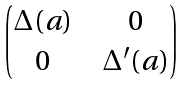Convert formula to latex. <formula><loc_0><loc_0><loc_500><loc_500>\begin{pmatrix} \Delta ( a ) \ & \ 0 \\ 0 \ & \ \Delta ^ { \prime } ( a ) \end{pmatrix}</formula> 